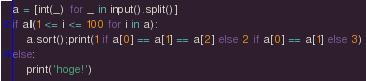<code> <loc_0><loc_0><loc_500><loc_500><_Python_>a = [int(_) for _ in input().split()]
if all(1 <= i <= 100 for i in a):
    a.sort();print(1 if a[0] == a[1] == a[2] else 2 if a[0] == a[1] else 3)
else:
    print('hoge!')</code> 